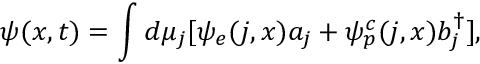<formula> <loc_0><loc_0><loc_500><loc_500>\psi ( x , t ) = \int d \mu _ { j } [ \psi _ { e } ( j , x ) a _ { j } + \psi _ { p } ^ { c } ( j , x ) b _ { j } ^ { \dagger } ] ,</formula> 